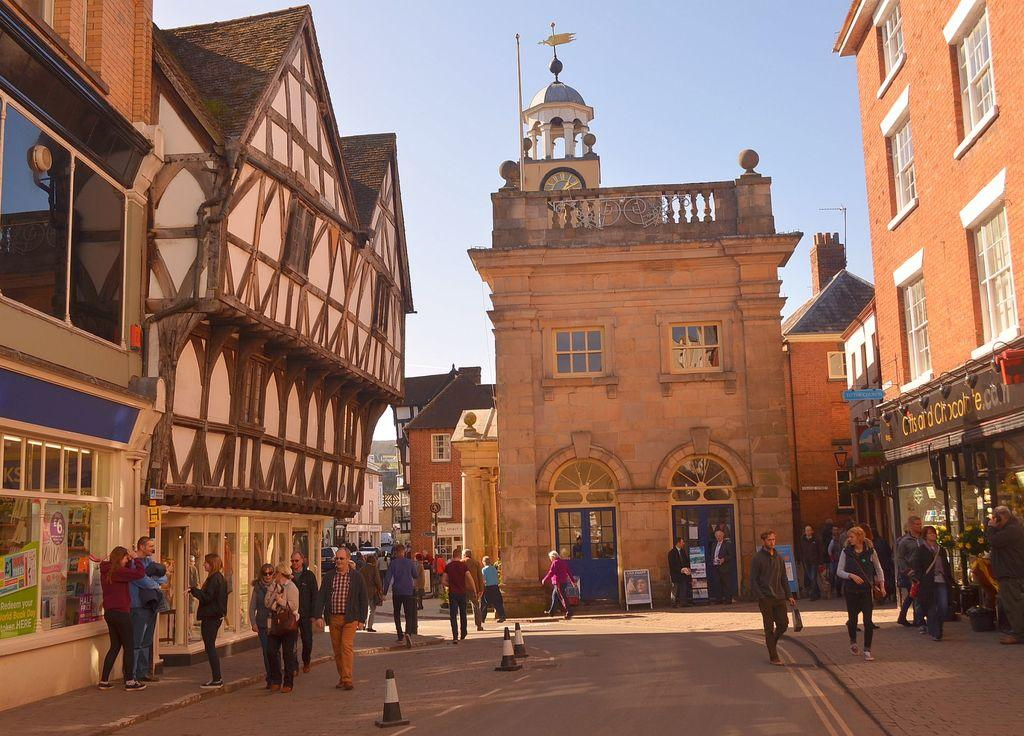What is happening on the road in the image? There are people on the road in the image. What type of structures can be seen in the image? There are buildings with windows in the image. What are the vertical structures in the image? There are poles in the image. What type of signage is present in the image? There are posters in the image. What is on the road besides people? There are objects on the road in the image. What can be seen above the structures in the image? The sky is visible in the image. What type of government is depicted on the posters in the image? There is no indication of any government or political content on the posters in the image. Can you see a plane flying in the sky in the image? There is no plane visible in the sky in the image. 